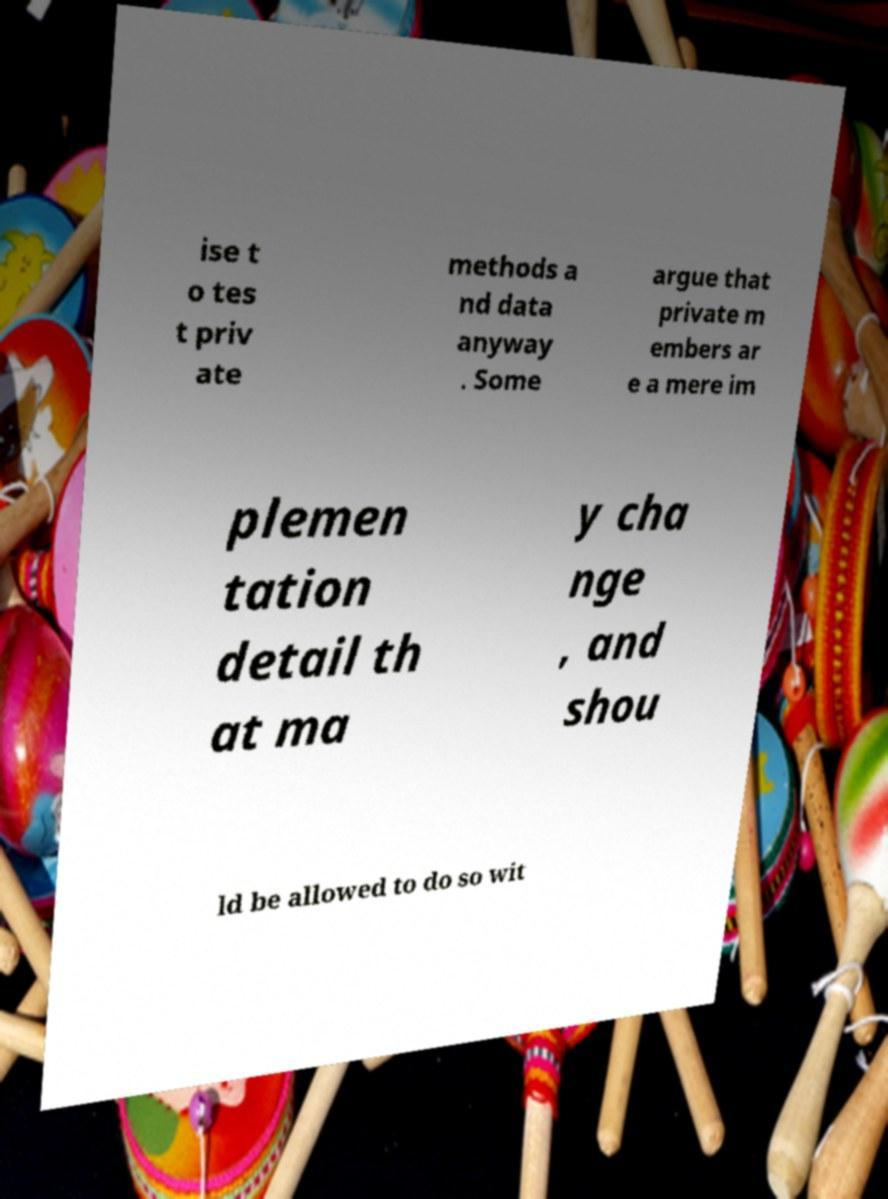Can you accurately transcribe the text from the provided image for me? ise t o tes t priv ate methods a nd data anyway . Some argue that private m embers ar e a mere im plemen tation detail th at ma y cha nge , and shou ld be allowed to do so wit 